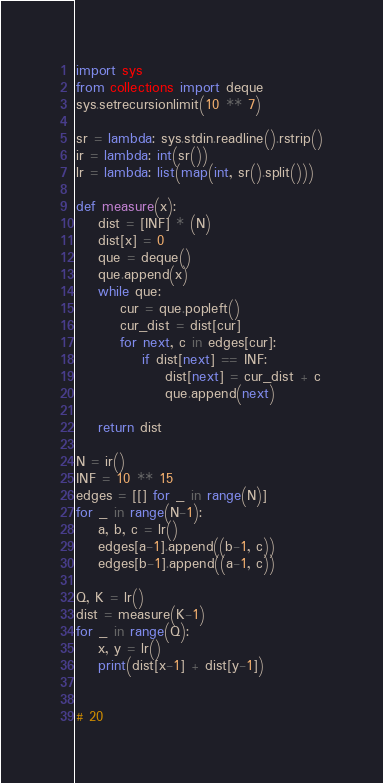Convert code to text. <code><loc_0><loc_0><loc_500><loc_500><_Python_>import sys
from collections import deque
sys.setrecursionlimit(10 ** 7)

sr = lambda: sys.stdin.readline().rstrip()
ir = lambda: int(sr())
lr = lambda: list(map(int, sr().split()))

def measure(x):
    dist = [INF] * (N)
    dist[x] = 0
    que = deque()
    que.append(x)
    while que:
        cur = que.popleft()
        cur_dist = dist[cur]
        for next, c in edges[cur]:
            if dist[next] == INF:
                dist[next] = cur_dist + c
                que.append(next)
    
    return dist

N = ir()
INF = 10 ** 15
edges = [[] for _ in range(N)]
for _ in range(N-1):
    a, b, c = lr()
    edges[a-1].append((b-1, c))
    edges[b-1].append((a-1, c))

Q, K = lr()
dist = measure(K-1)
for _ in range(Q):
    x, y = lr()
    print(dist[x-1] + dist[y-1])


# 20
</code> 